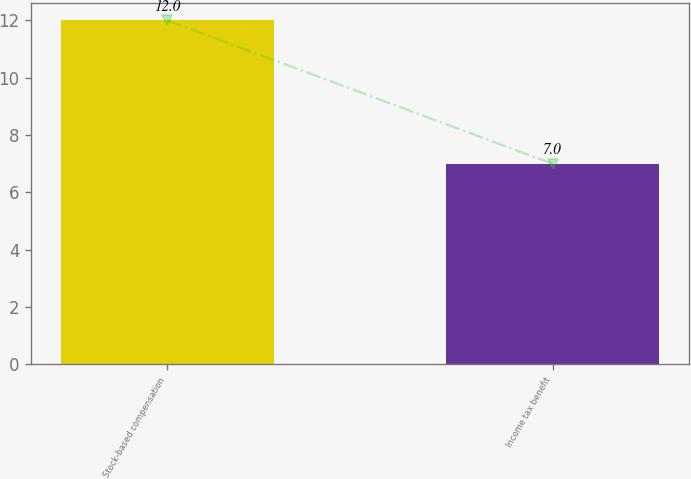Convert chart. <chart><loc_0><loc_0><loc_500><loc_500><bar_chart><fcel>Stock-based compensation<fcel>Income tax benefit<nl><fcel>12<fcel>7<nl></chart> 